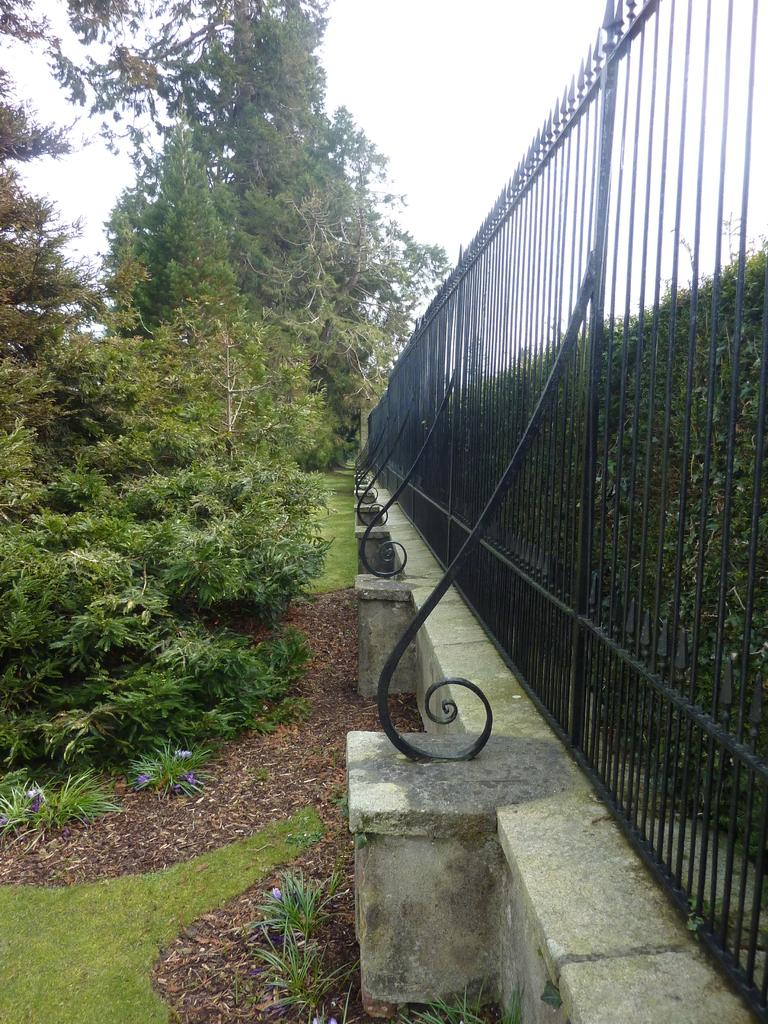What type of vegetation can be seen in the image? There are trees and plants in the image. What type of barrier is present in the image? There is an iron fence in the image. What type of coat is the farmer wearing in the image? There is no farmer present in the image, so it is not possible to determine what type of coat they might be wearing. 